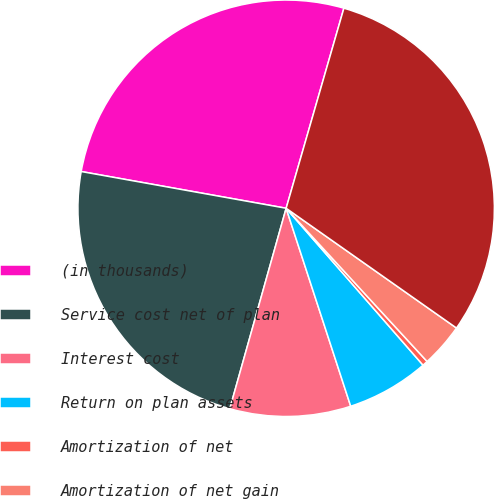Convert chart. <chart><loc_0><loc_0><loc_500><loc_500><pie_chart><fcel>(in thousands)<fcel>Service cost net of plan<fcel>Interest cost<fcel>Return on plan assets<fcel>Amortization of net<fcel>Amortization of net gain<fcel>Net periodic pension cost<nl><fcel>26.65%<fcel>23.46%<fcel>9.38%<fcel>6.4%<fcel>0.42%<fcel>3.41%<fcel>30.28%<nl></chart> 